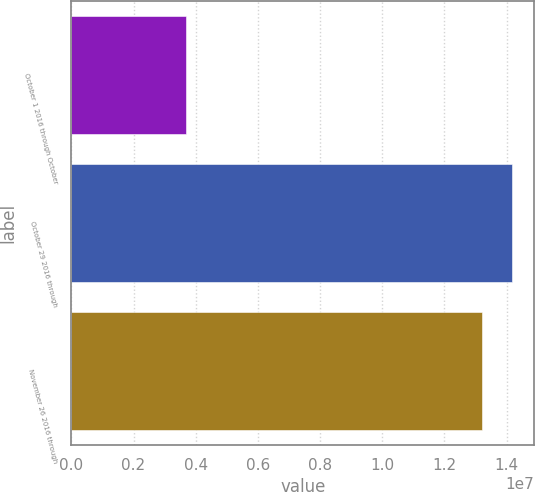Convert chart to OTSL. <chart><loc_0><loc_0><loc_500><loc_500><bar_chart><fcel>October 1 2016 through October<fcel>October 29 2016 through<fcel>November 26 2016 through<nl><fcel>3.67491e+06<fcel>1.41745e+07<fcel>1.32028e+07<nl></chart> 